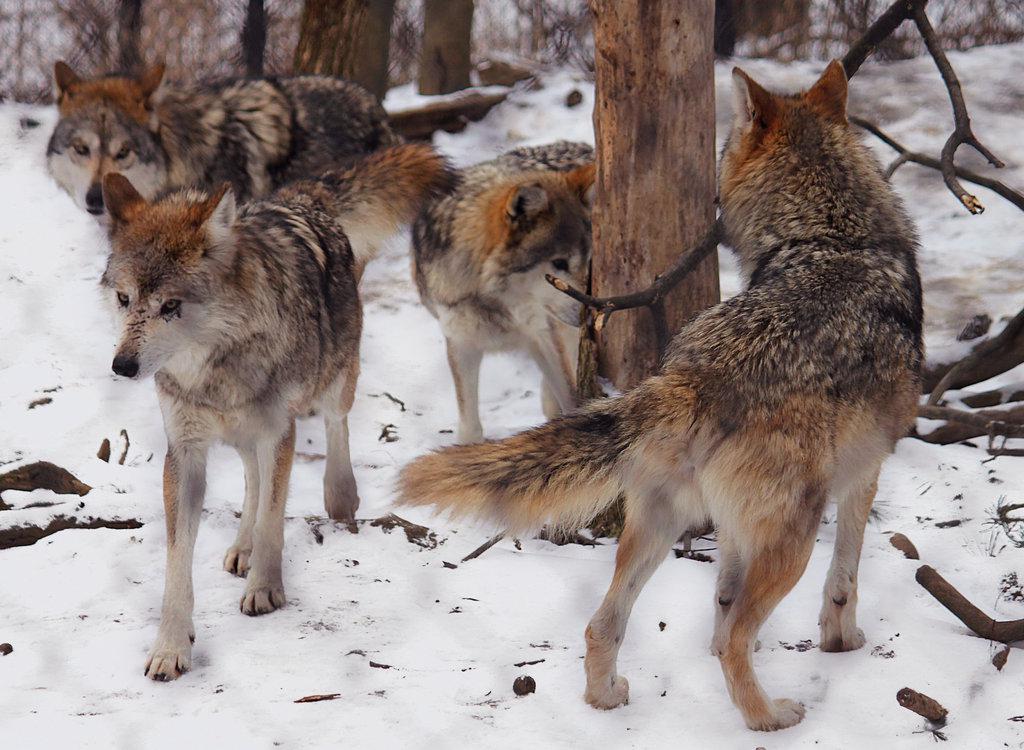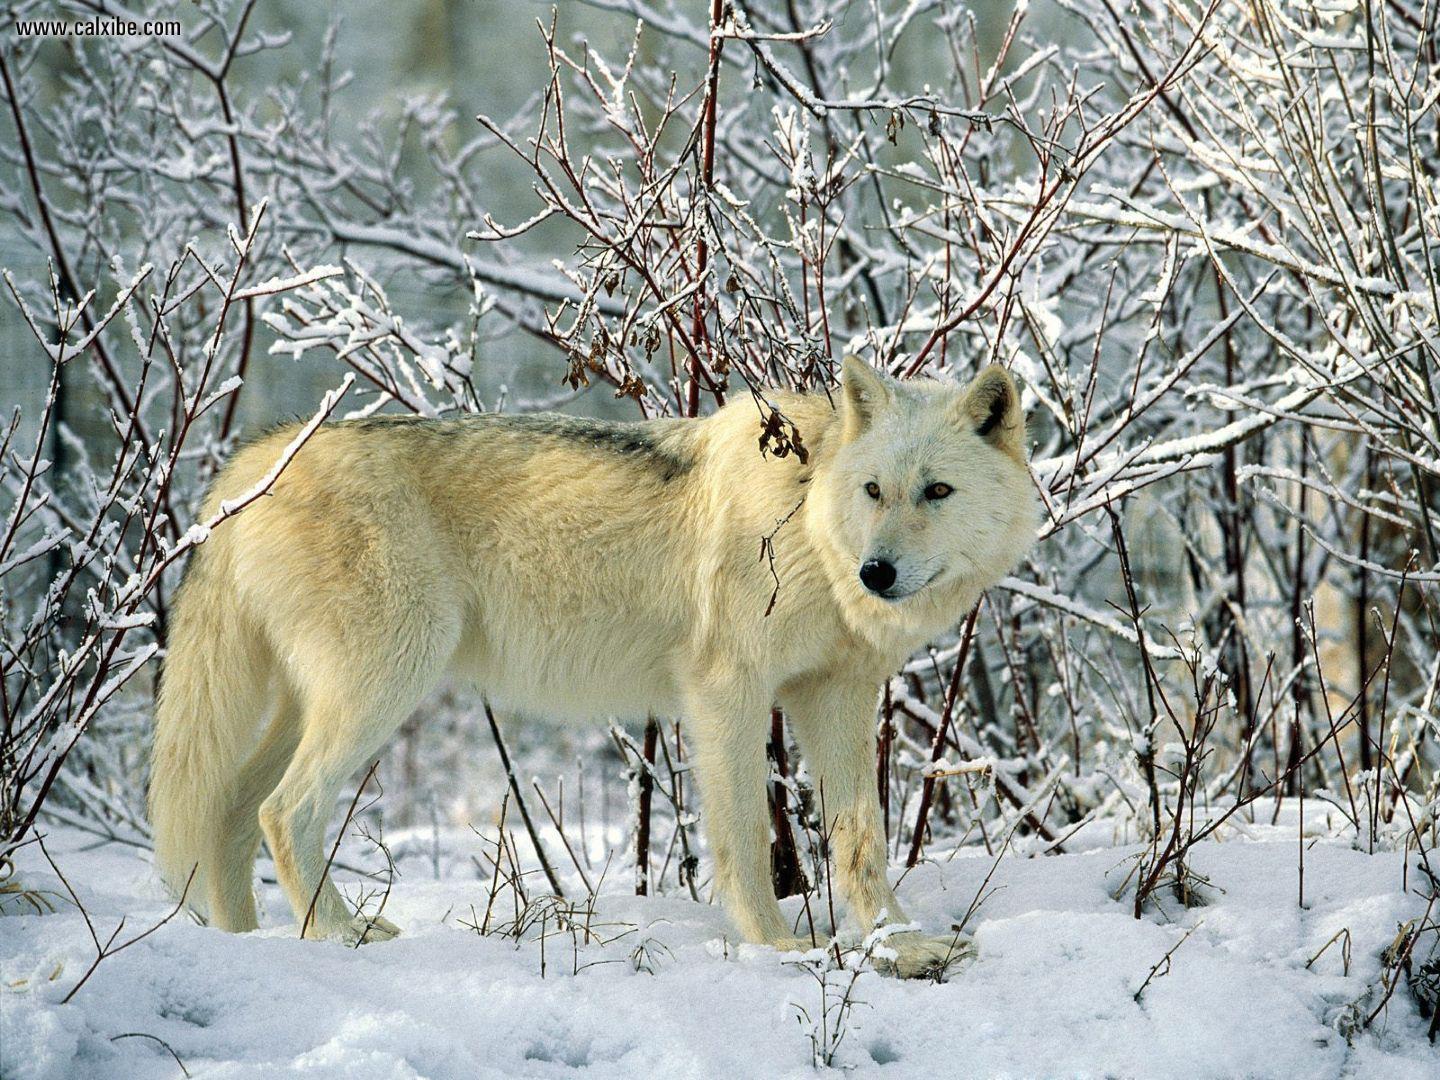The first image is the image on the left, the second image is the image on the right. Examine the images to the left and right. Is the description "There is no more than two wolves in the left image." accurate? Answer yes or no. No. The first image is the image on the left, the second image is the image on the right. For the images shown, is this caption "One image shows a wolf standing on snow in front of trees with its body turned rightward and its head facing the camera." true? Answer yes or no. Yes. 